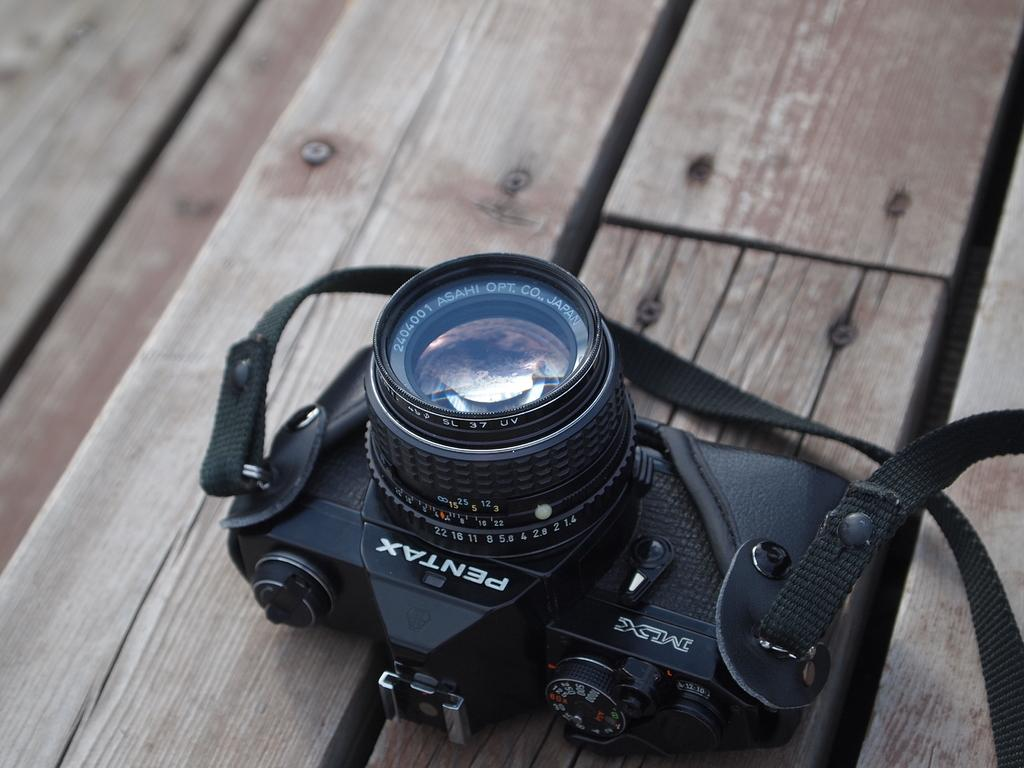What object is the main focus of the image? There is a black camera in the image. Can you describe the surface on which the camera is placed? The camera is on a wooden table. How many rings are stacked on the camera in the image? There are no rings present in the image; it only features a black camera on a wooden table. 